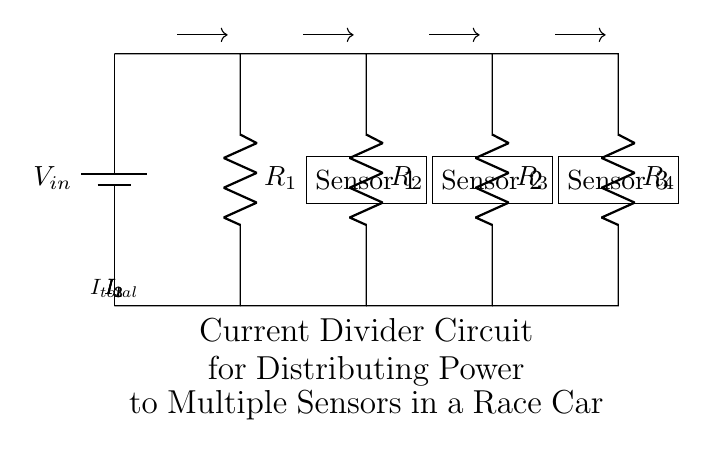What is the total input voltage of this circuit? The circuit has a battery labeled as V_in connected to the top. The input voltage is defined as the voltage supplied by this battery.
Answer: V_in How many resistors are present in the circuit? The diagram clearly shows four resistors (R1, R2, R3, and R4) connected in a way that they create parallel branches for the current divider.
Answer: Four What is the current flowing through the first branch? The circuit shows the first branch with a label I1 indicating the current flowing through the resistor R2 towards Sensor 1. This is denoted with an arrow and the label for that current.
Answer: I1 What types of components are used in this circuit? The components involved in this circuit include a battery, resistors, and sensors. Visual inspection reveals these specific types of components.
Answer: Battery, resistors, sensors If the total current is 10A, what is the relationship of currents through the branches? In a current divider, the total current splits among branches inversely proportional to resistance values. Therefore, knowing the resistance values, you could calculate each current I1, I2, and I3. For example, if R2 is lower than R3 and R4, then I2 would be larger than I1 and I3.
Answer: Inversely proportional to resistances What is the purpose of this current divider circuit in a race car? The diagram indicates that the resistors lead to sensors. In race cars, this circuit is designed to distribute power efficiently to multiple sensors, allowing them to function properly without overloading.
Answer: Power distribution to sensors 